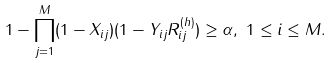Convert formula to latex. <formula><loc_0><loc_0><loc_500><loc_500>& 1 - \prod _ { j = 1 } ^ { M } ( 1 - X _ { i j } ) ( 1 - Y _ { i j } R ^ { ( h ) } _ { i j } ) \geq \alpha , \ 1 \leq i \leq M .</formula> 